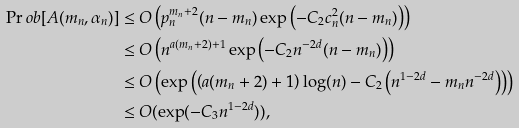Convert formula to latex. <formula><loc_0><loc_0><loc_500><loc_500>\Pr o b [ A ( m _ { n } , \alpha _ { n } ) ] & \leq O \left ( p ^ { m _ { n } + 2 } _ { n } ( n - m _ { n } ) \exp \left ( - C _ { 2 } c ^ { 2 } _ { n } ( n - m _ { n } ) \right ) \right ) \\ & \leq O \left ( n ^ { a ( m _ { n } + 2 ) + 1 } \exp \left ( - C _ { 2 } n ^ { - 2 d } ( n - m _ { n } ) \right ) \right ) \\ & \leq O \left ( \exp \left ( \left ( a ( m _ { n } + 2 ) + 1 \right ) \log ( n ) - C _ { 2 } \left ( n ^ { 1 - 2 d } - m _ { n } n ^ { - 2 d } \right ) \right ) \right ) \\ & \leq O ( \exp ( - C _ { 3 } n ^ { 1 - 2 d } ) ) ,</formula> 